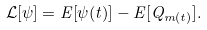<formula> <loc_0><loc_0><loc_500><loc_500>\mathcal { L } [ \psi ] = E [ \psi ( t ) ] - E [ Q _ { m ( t ) } ] .</formula> 